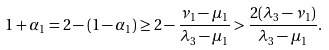<formula> <loc_0><loc_0><loc_500><loc_500>1 + \alpha _ { 1 } = 2 - ( 1 - \alpha _ { 1 } ) \geq 2 - \frac { \nu _ { 1 } - \mu _ { 1 } } { \lambda _ { 3 } - \mu _ { 1 } } > \frac { 2 ( \lambda _ { 3 } - \nu _ { 1 } ) } { \lambda _ { 3 } - \mu _ { 1 } } .</formula> 